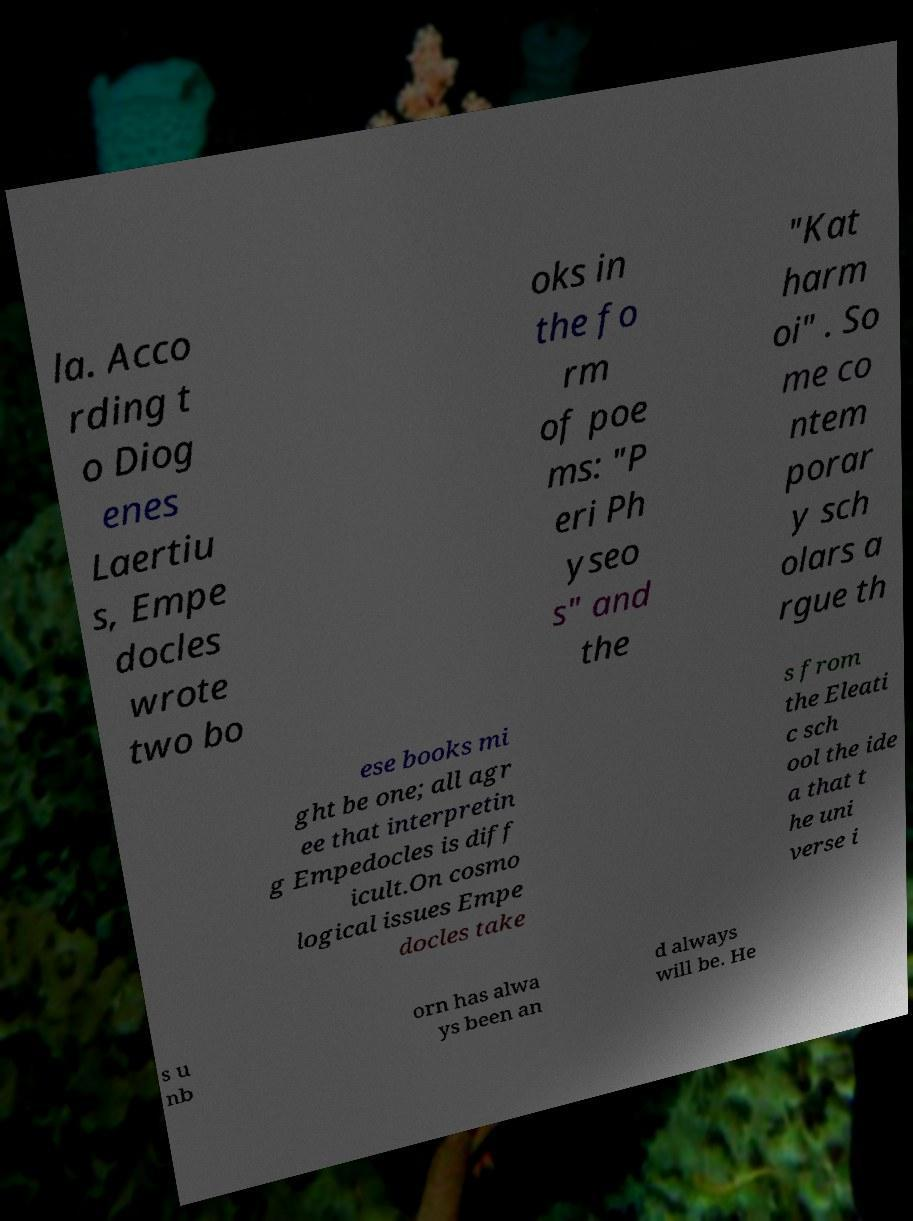For documentation purposes, I need the text within this image transcribed. Could you provide that? la. Acco rding t o Diog enes Laertiu s, Empe docles wrote two bo oks in the fo rm of poe ms: "P eri Ph yseo s" and the "Kat harm oi" . So me co ntem porar y sch olars a rgue th ese books mi ght be one; all agr ee that interpretin g Empedocles is diff icult.On cosmo logical issues Empe docles take s from the Eleati c sch ool the ide a that t he uni verse i s u nb orn has alwa ys been an d always will be. He 